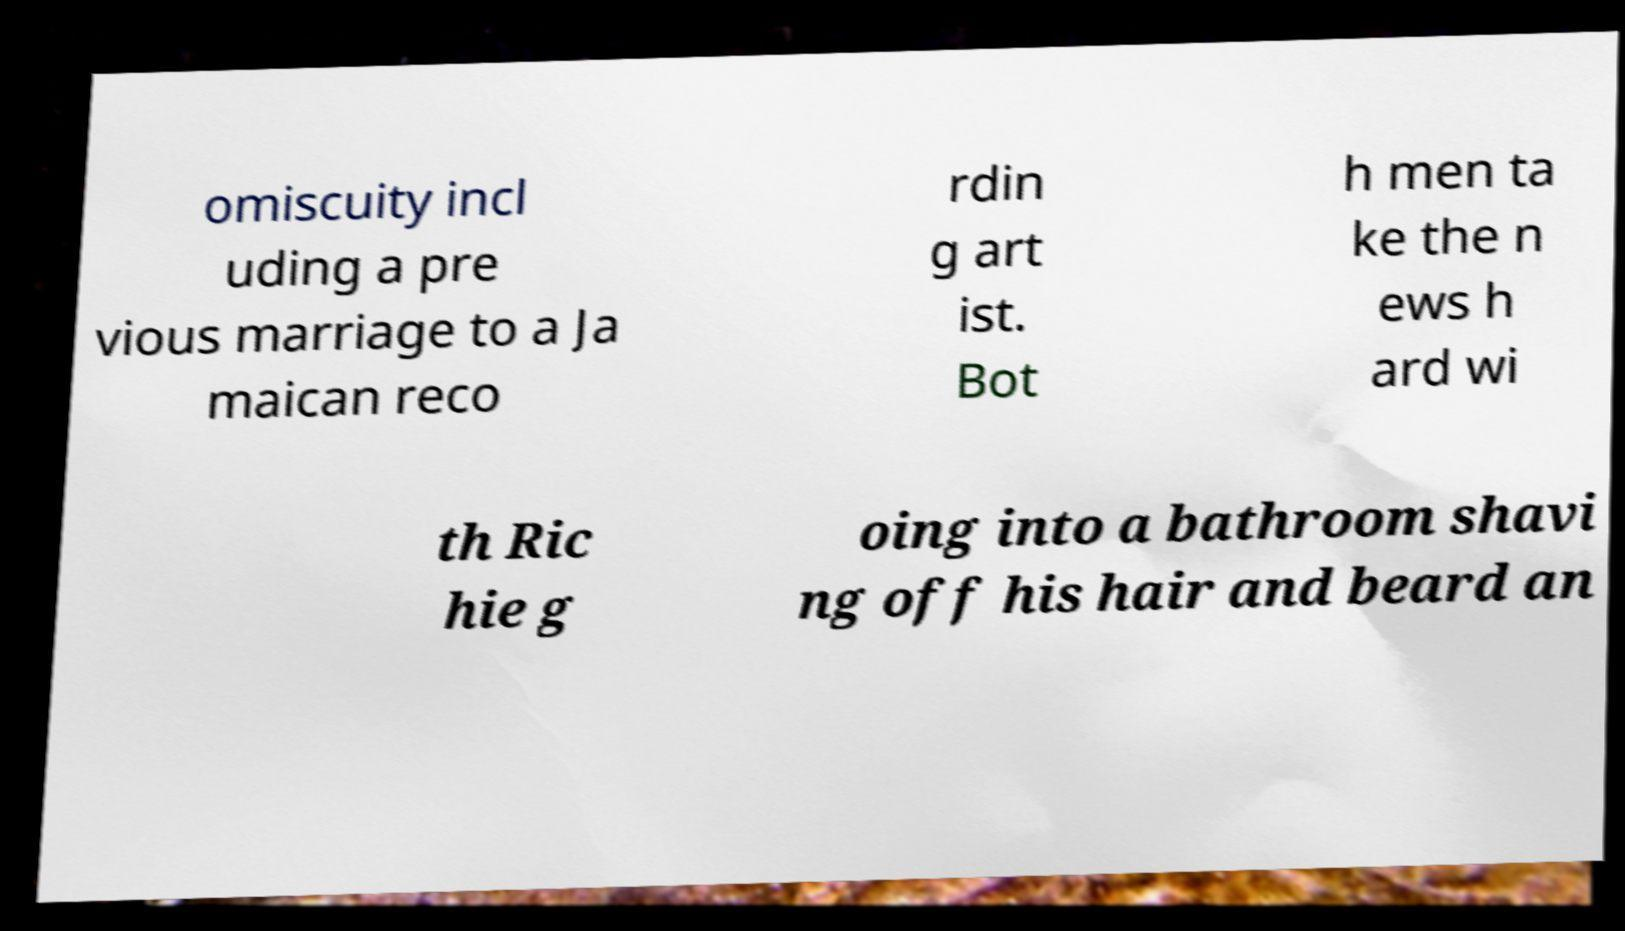I need the written content from this picture converted into text. Can you do that? omiscuity incl uding a pre vious marriage to a Ja maican reco rdin g art ist. Bot h men ta ke the n ews h ard wi th Ric hie g oing into a bathroom shavi ng off his hair and beard an 